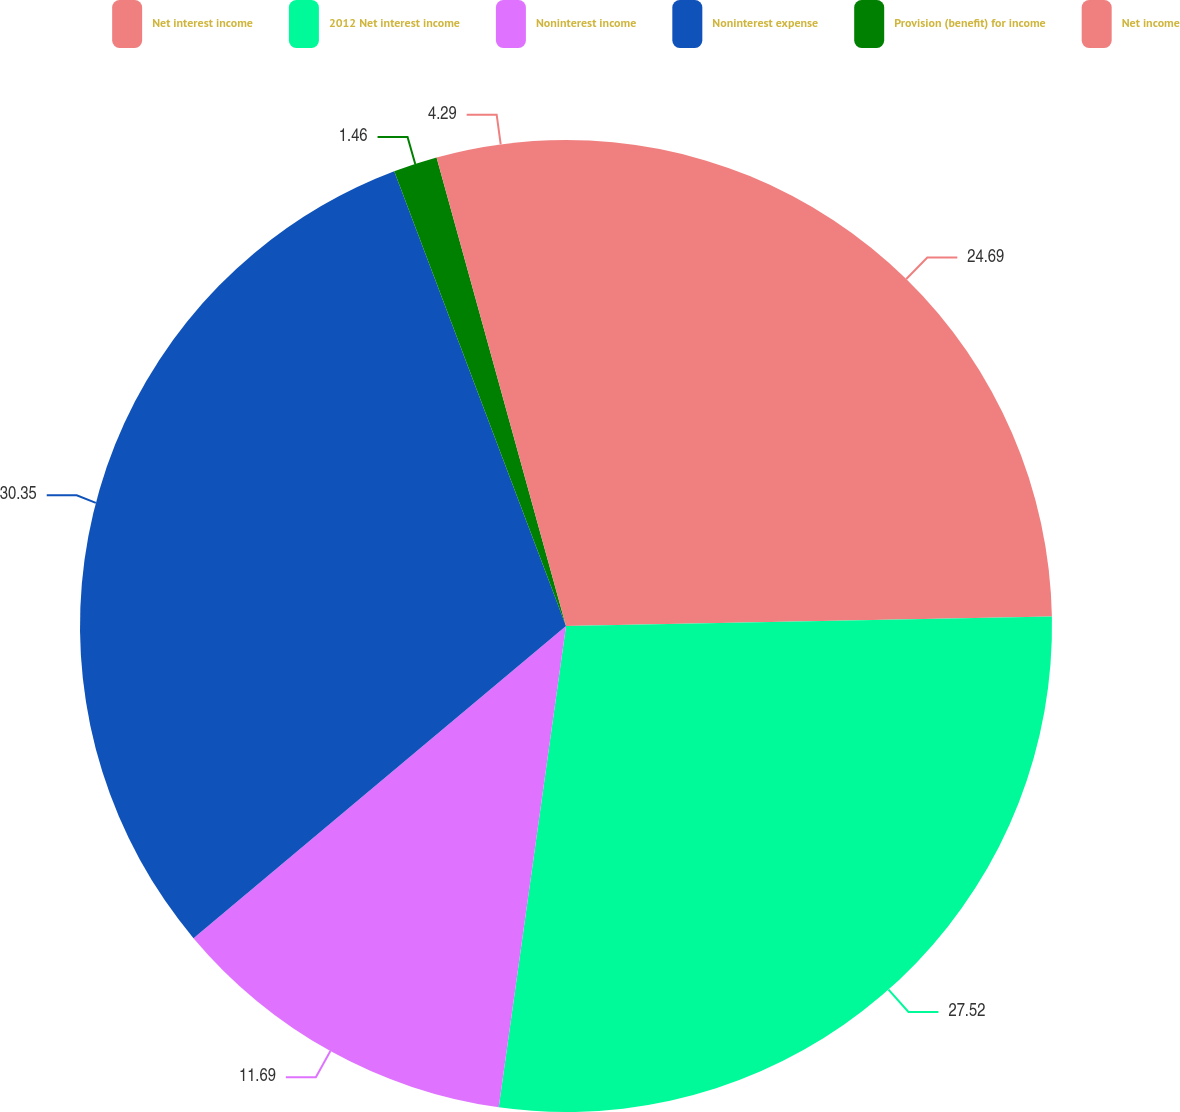<chart> <loc_0><loc_0><loc_500><loc_500><pie_chart><fcel>Net interest income<fcel>2012 Net interest income<fcel>Noninterest income<fcel>Noninterest expense<fcel>Provision (benefit) for income<fcel>Net income<nl><fcel>24.69%<fcel>27.52%<fcel>11.69%<fcel>30.35%<fcel>1.46%<fcel>4.29%<nl></chart> 